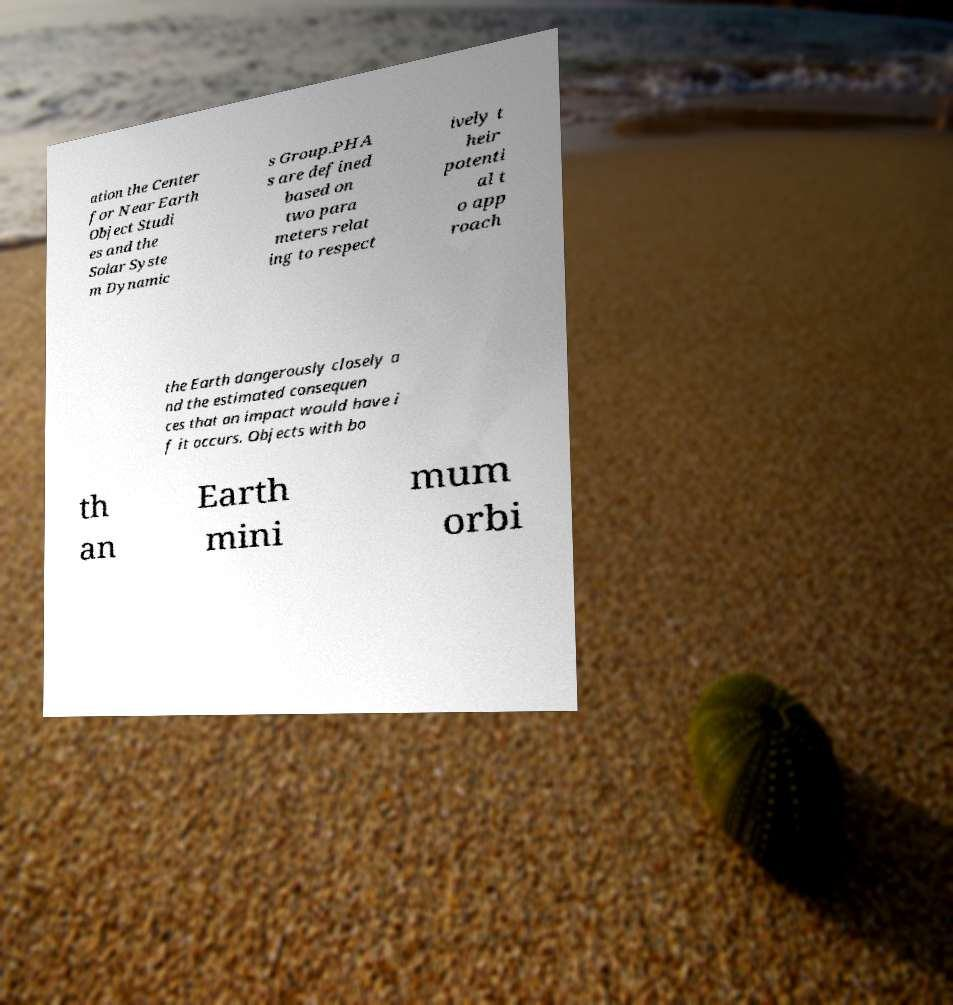There's text embedded in this image that I need extracted. Can you transcribe it verbatim? ation the Center for Near Earth Object Studi es and the Solar Syste m Dynamic s Group.PHA s are defined based on two para meters relat ing to respect ively t heir potenti al t o app roach the Earth dangerously closely a nd the estimated consequen ces that an impact would have i f it occurs. Objects with bo th an Earth mini mum orbi 